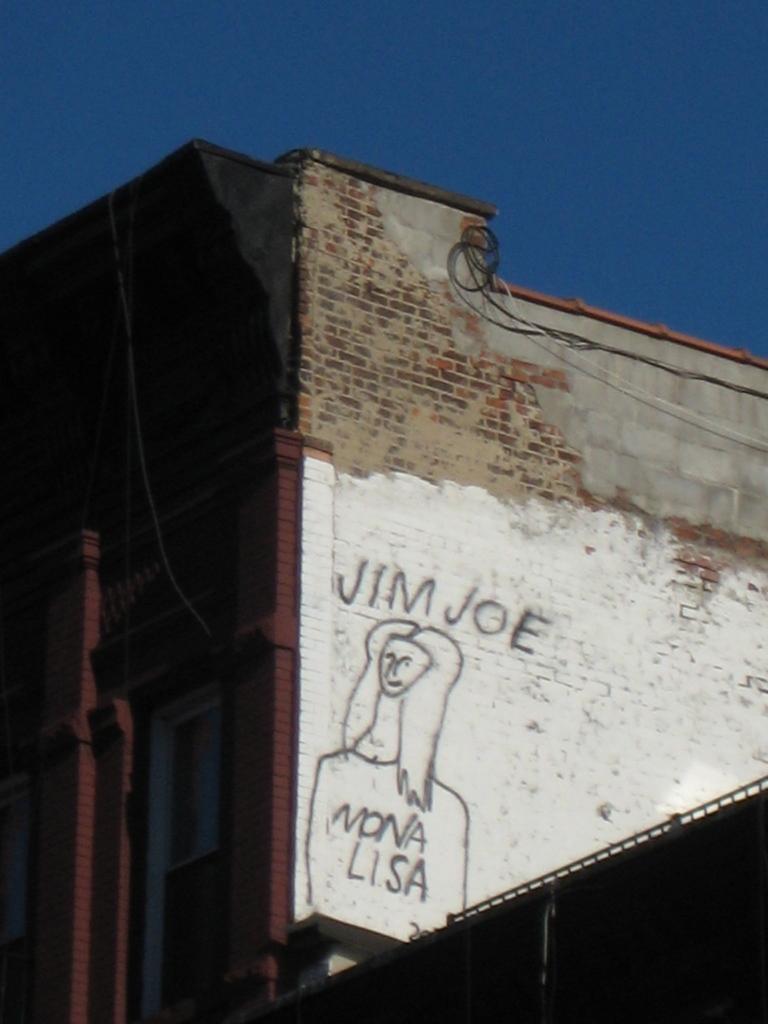How would you summarize this image in a sentence or two? As we can see in the image there is a building, drawing of a woman and sky. 